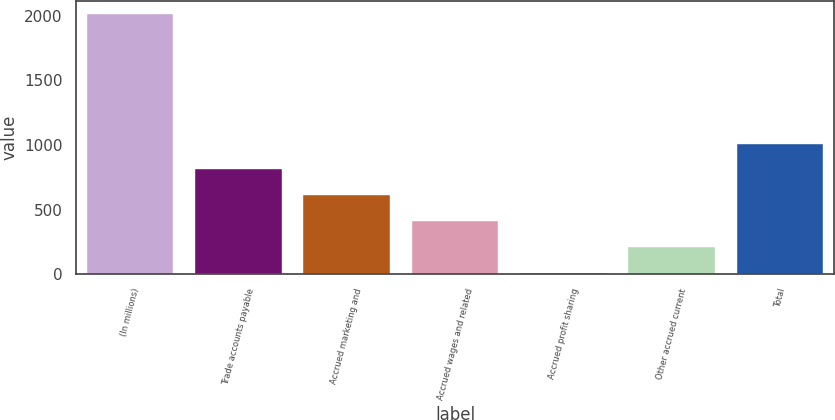Convert chart. <chart><loc_0><loc_0><loc_500><loc_500><bar_chart><fcel>(In millions)<fcel>Trade accounts payable<fcel>Accrued marketing and<fcel>Accrued wages and related<fcel>Accrued profit sharing<fcel>Other accrued current<fcel>Total<nl><fcel>2011<fcel>810.7<fcel>610.65<fcel>410.6<fcel>10.5<fcel>210.55<fcel>1010.75<nl></chart> 